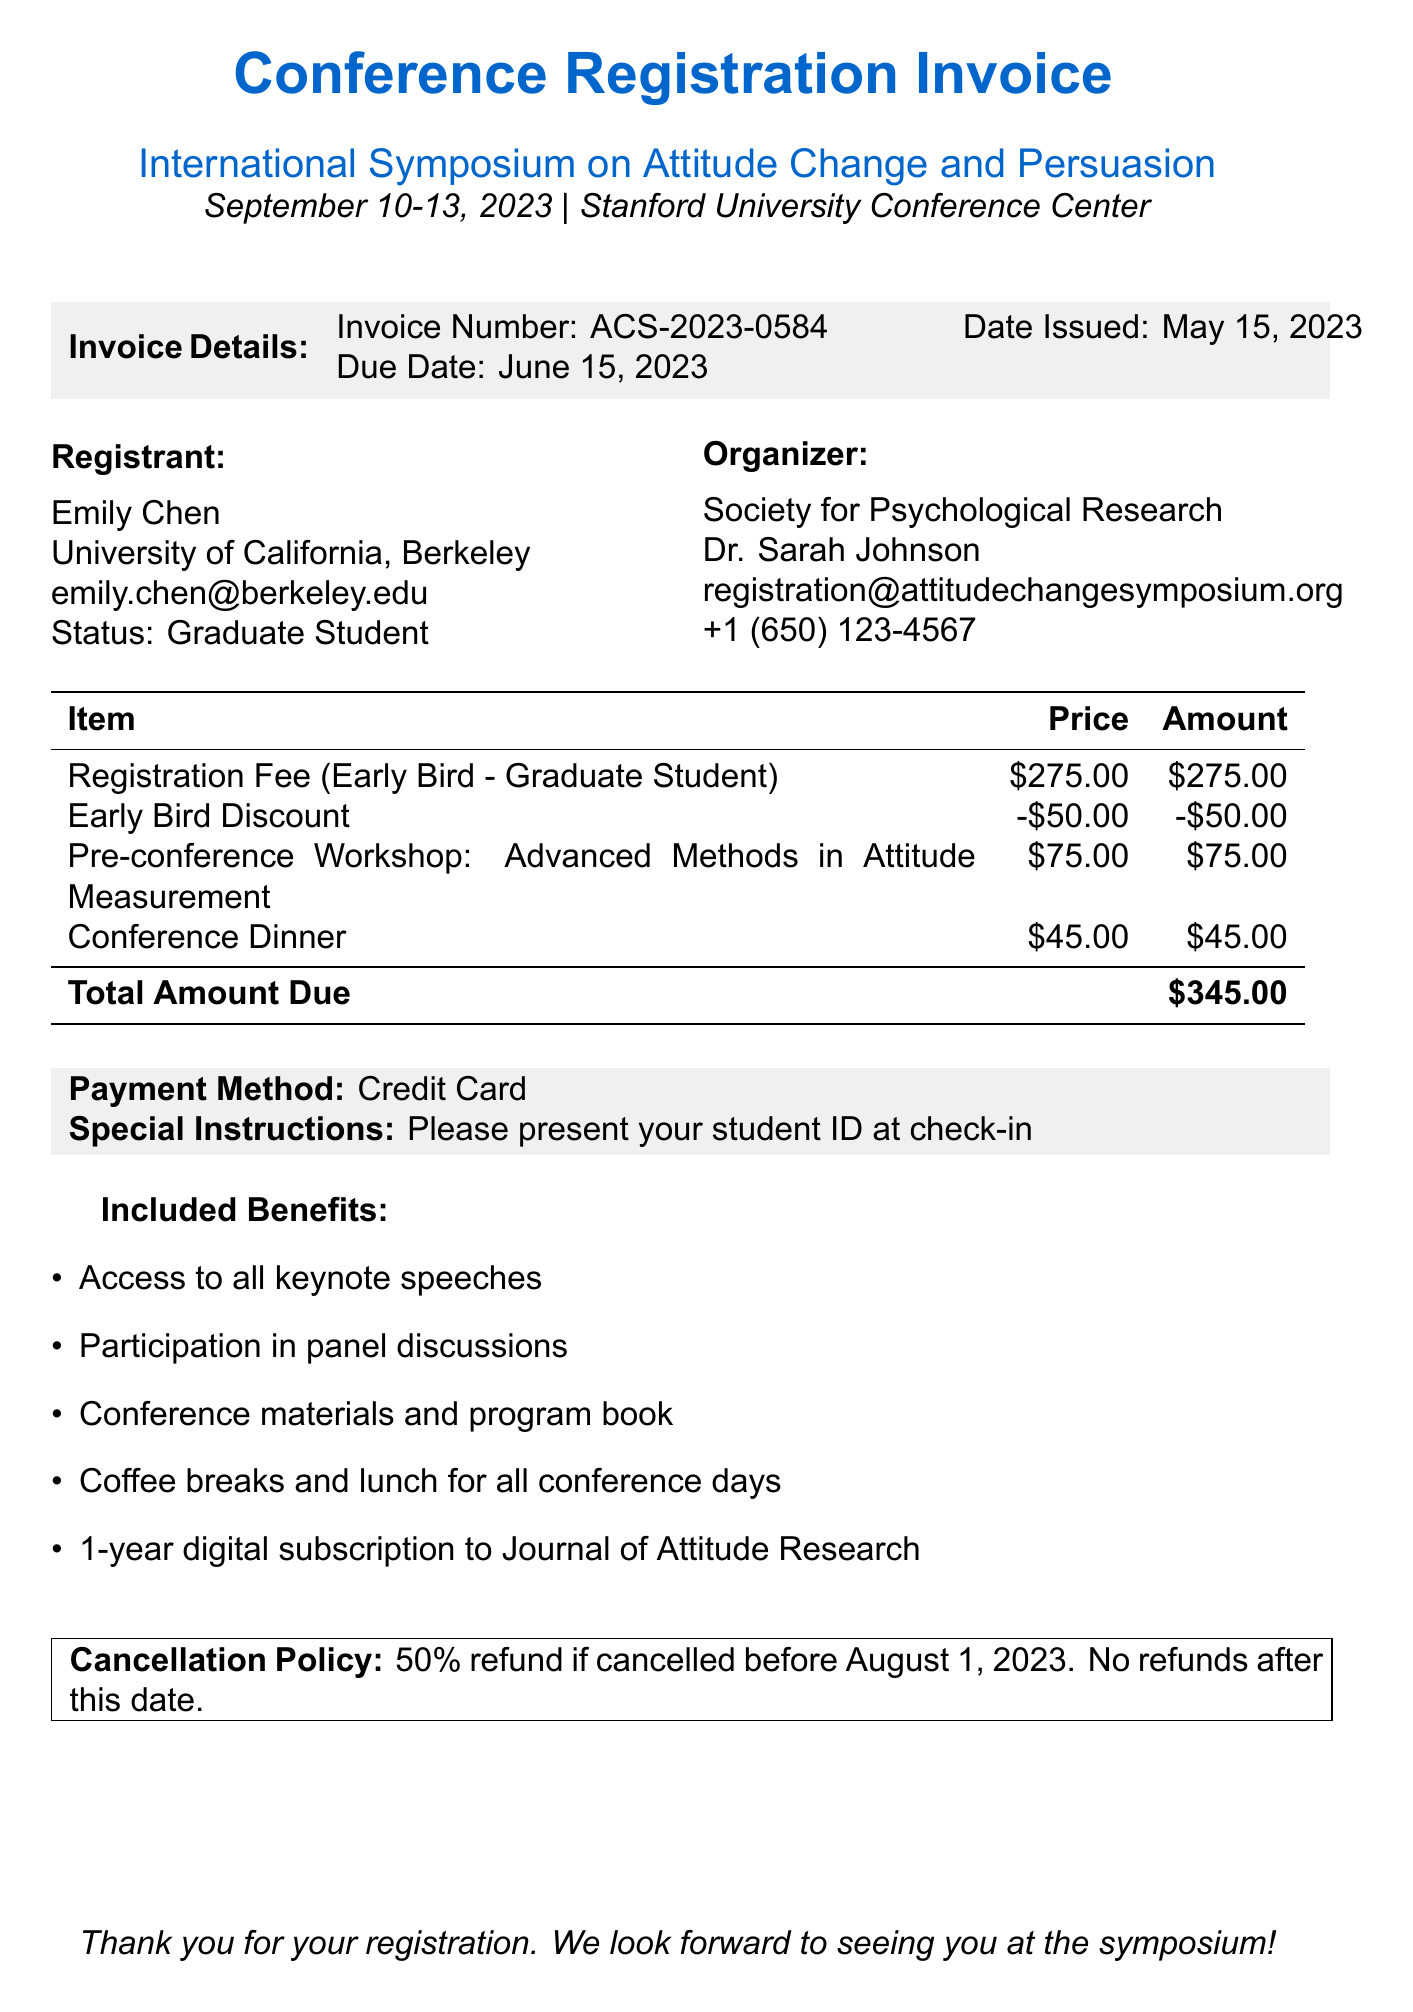what is the invoice number? The invoice number listed in the document is provided to identify the specific registration, which is ACS-2023-0584.
Answer: ACS-2023-0584 what is the total amount due? The total amount due is the sum of the registration fee and additional items minus the discount, which is shown as $345.00 in the document.
Answer: $345.00 who is the registrant's institution? The document specifies the institution of the registrant, which is the University of California, Berkeley.
Answer: University of California, Berkeley what is the early bird discount amount? The document mentions an early bird discount, which is a deduction of $50.00 from the registration fee.
Answer: $50.00 what is the cancellation policy? The cancellation policy details the refund amount, specifically that there is a 50% refund if cancelled before a certain date, which is August 1, 2023.
Answer: 50% refund if cancelled before August 1, 2023 how long is the digital subscription to the Journal of Attitude Research? The included benefits mention a 1-year digital subscription, indicating the duration of access to this resource.
Answer: 1 year when is the conference date? The document specifies the dates for the conference, identifying it occurs from September 10 to September 13, 2023.
Answer: September 10 to September 13, 2023 what payment method was used for the registration? The document indicates the payment method utilized for registration is by credit card, which is noted under payment details.
Answer: Credit Card what special instruction is given to the registrant? The special instructions mentioned in the document specify that the registrant should present their student ID at check-in.
Answer: Please present your student ID at check-in 